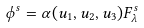Convert formula to latex. <formula><loc_0><loc_0><loc_500><loc_500>\phi ^ { s } = \alpha ( u _ { 1 } , u _ { 2 } , u _ { 3 } ) F ^ { s } _ { \lambda }</formula> 